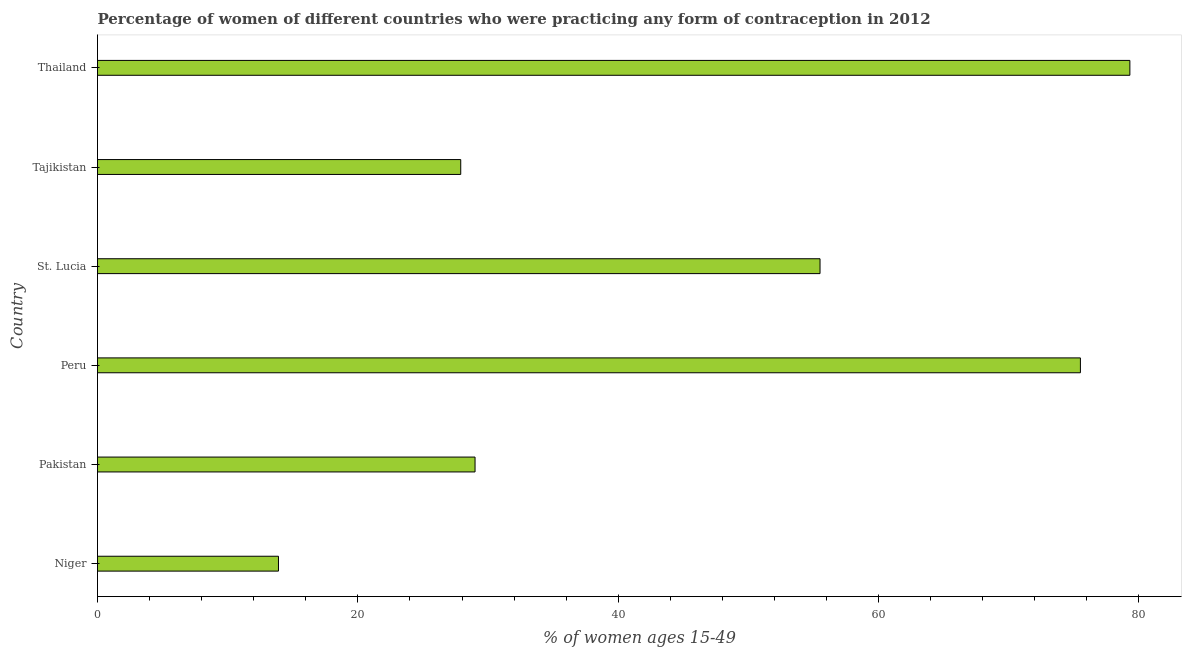Does the graph contain any zero values?
Give a very brief answer. No. What is the title of the graph?
Provide a succinct answer. Percentage of women of different countries who were practicing any form of contraception in 2012. What is the label or title of the X-axis?
Your response must be concise. % of women ages 15-49. What is the label or title of the Y-axis?
Offer a terse response. Country. What is the contraceptive prevalence in Thailand?
Offer a terse response. 79.3. Across all countries, what is the maximum contraceptive prevalence?
Your answer should be very brief. 79.3. Across all countries, what is the minimum contraceptive prevalence?
Make the answer very short. 13.9. In which country was the contraceptive prevalence maximum?
Your response must be concise. Thailand. In which country was the contraceptive prevalence minimum?
Offer a terse response. Niger. What is the sum of the contraceptive prevalence?
Keep it short and to the point. 281.1. What is the difference between the contraceptive prevalence in Niger and Peru?
Provide a short and direct response. -61.6. What is the average contraceptive prevalence per country?
Your answer should be very brief. 46.85. What is the median contraceptive prevalence?
Provide a succinct answer. 42.25. What is the ratio of the contraceptive prevalence in Peru to that in St. Lucia?
Offer a terse response. 1.36. Is the difference between the contraceptive prevalence in Niger and Peru greater than the difference between any two countries?
Your response must be concise. No. Is the sum of the contraceptive prevalence in Peru and Tajikistan greater than the maximum contraceptive prevalence across all countries?
Your answer should be very brief. Yes. What is the difference between the highest and the lowest contraceptive prevalence?
Your response must be concise. 65.4. Are all the bars in the graph horizontal?
Your response must be concise. Yes. How many countries are there in the graph?
Your answer should be compact. 6. Are the values on the major ticks of X-axis written in scientific E-notation?
Give a very brief answer. No. What is the % of women ages 15-49 in Peru?
Provide a succinct answer. 75.5. What is the % of women ages 15-49 in St. Lucia?
Offer a terse response. 55.5. What is the % of women ages 15-49 in Tajikistan?
Offer a terse response. 27.9. What is the % of women ages 15-49 in Thailand?
Your answer should be compact. 79.3. What is the difference between the % of women ages 15-49 in Niger and Pakistan?
Keep it short and to the point. -15.1. What is the difference between the % of women ages 15-49 in Niger and Peru?
Give a very brief answer. -61.6. What is the difference between the % of women ages 15-49 in Niger and St. Lucia?
Make the answer very short. -41.6. What is the difference between the % of women ages 15-49 in Niger and Thailand?
Provide a short and direct response. -65.4. What is the difference between the % of women ages 15-49 in Pakistan and Peru?
Give a very brief answer. -46.5. What is the difference between the % of women ages 15-49 in Pakistan and St. Lucia?
Your answer should be compact. -26.5. What is the difference between the % of women ages 15-49 in Pakistan and Tajikistan?
Your answer should be very brief. 1.1. What is the difference between the % of women ages 15-49 in Pakistan and Thailand?
Your answer should be compact. -50.3. What is the difference between the % of women ages 15-49 in Peru and St. Lucia?
Your answer should be very brief. 20. What is the difference between the % of women ages 15-49 in Peru and Tajikistan?
Make the answer very short. 47.6. What is the difference between the % of women ages 15-49 in Peru and Thailand?
Make the answer very short. -3.8. What is the difference between the % of women ages 15-49 in St. Lucia and Tajikistan?
Keep it short and to the point. 27.6. What is the difference between the % of women ages 15-49 in St. Lucia and Thailand?
Provide a succinct answer. -23.8. What is the difference between the % of women ages 15-49 in Tajikistan and Thailand?
Keep it short and to the point. -51.4. What is the ratio of the % of women ages 15-49 in Niger to that in Pakistan?
Make the answer very short. 0.48. What is the ratio of the % of women ages 15-49 in Niger to that in Peru?
Your answer should be very brief. 0.18. What is the ratio of the % of women ages 15-49 in Niger to that in Tajikistan?
Offer a terse response. 0.5. What is the ratio of the % of women ages 15-49 in Niger to that in Thailand?
Your answer should be very brief. 0.17. What is the ratio of the % of women ages 15-49 in Pakistan to that in Peru?
Give a very brief answer. 0.38. What is the ratio of the % of women ages 15-49 in Pakistan to that in St. Lucia?
Keep it short and to the point. 0.52. What is the ratio of the % of women ages 15-49 in Pakistan to that in Tajikistan?
Keep it short and to the point. 1.04. What is the ratio of the % of women ages 15-49 in Pakistan to that in Thailand?
Your response must be concise. 0.37. What is the ratio of the % of women ages 15-49 in Peru to that in St. Lucia?
Your answer should be very brief. 1.36. What is the ratio of the % of women ages 15-49 in Peru to that in Tajikistan?
Provide a succinct answer. 2.71. What is the ratio of the % of women ages 15-49 in Peru to that in Thailand?
Your answer should be compact. 0.95. What is the ratio of the % of women ages 15-49 in St. Lucia to that in Tajikistan?
Ensure brevity in your answer.  1.99. What is the ratio of the % of women ages 15-49 in St. Lucia to that in Thailand?
Make the answer very short. 0.7. What is the ratio of the % of women ages 15-49 in Tajikistan to that in Thailand?
Keep it short and to the point. 0.35. 